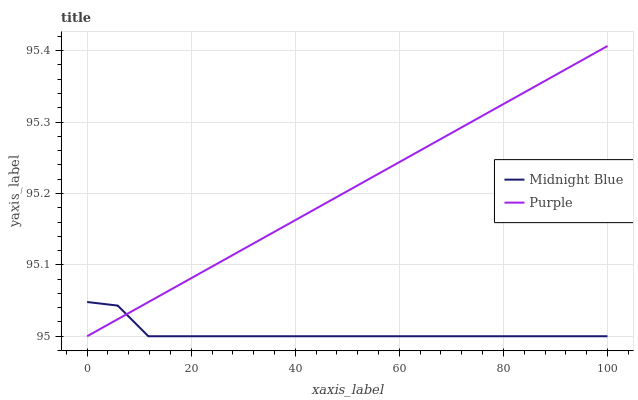Does Midnight Blue have the minimum area under the curve?
Answer yes or no. Yes. Does Purple have the maximum area under the curve?
Answer yes or no. Yes. Does Midnight Blue have the maximum area under the curve?
Answer yes or no. No. Is Purple the smoothest?
Answer yes or no. Yes. Is Midnight Blue the roughest?
Answer yes or no. Yes. Is Midnight Blue the smoothest?
Answer yes or no. No. Does Purple have the lowest value?
Answer yes or no. Yes. Does Purple have the highest value?
Answer yes or no. Yes. Does Midnight Blue have the highest value?
Answer yes or no. No. Does Midnight Blue intersect Purple?
Answer yes or no. Yes. Is Midnight Blue less than Purple?
Answer yes or no. No. Is Midnight Blue greater than Purple?
Answer yes or no. No. 